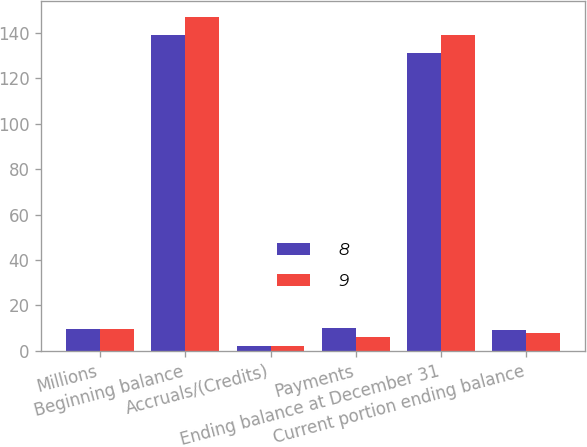Convert chart. <chart><loc_0><loc_0><loc_500><loc_500><stacked_bar_chart><ecel><fcel>Millions<fcel>Beginning balance<fcel>Accruals/(Credits)<fcel>Payments<fcel>Ending balance at December 31<fcel>Current portion ending balance<nl><fcel>8<fcel>9.5<fcel>139<fcel>2<fcel>10<fcel>131<fcel>9<nl><fcel>9<fcel>9.5<fcel>147<fcel>2<fcel>6<fcel>139<fcel>8<nl></chart> 